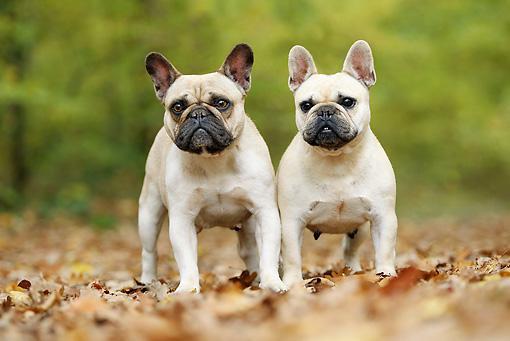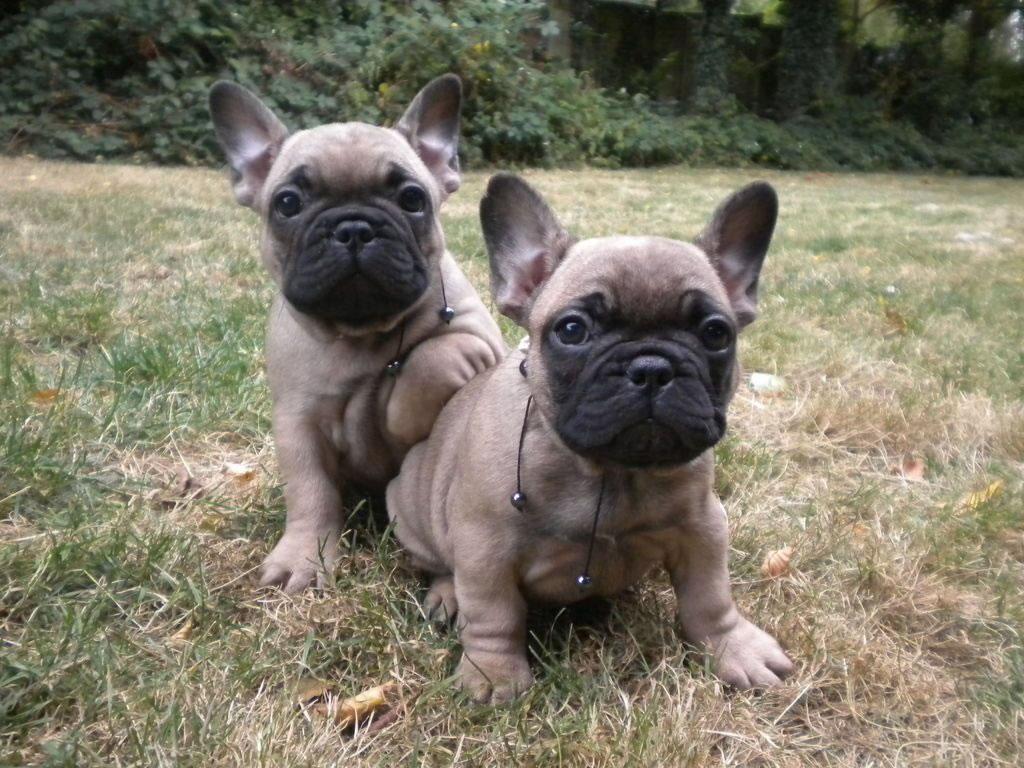The first image is the image on the left, the second image is the image on the right. Evaluate the accuracy of this statement regarding the images: "Two dogs are standing up in the image on the left.". Is it true? Answer yes or no. Yes. The first image is the image on the left, the second image is the image on the right. Considering the images on both sides, is "Each image contains a pair of big-eared dogs, and the pair on the left stand on all fours." valid? Answer yes or no. Yes. 